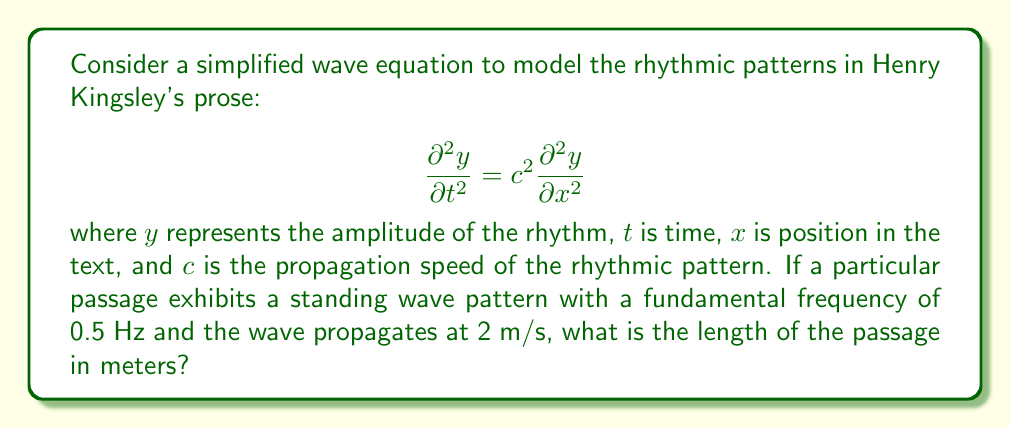Teach me how to tackle this problem. To solve this problem, we'll use the relationship between wavelength, frequency, and wave speed, along with the properties of standing waves.

Step 1: Recall the wave equation: $v = f\lambda$
Where $v$ is wave speed, $f$ is frequency, and $\lambda$ is wavelength.

Step 2: Rearrange the equation to solve for wavelength:
$\lambda = \frac{v}{f}$

Step 3: Substitute the given values:
$v = 2$ m/s (wave speed)
$f = 0.5$ Hz (fundamental frequency)

$\lambda = \frac{2}{0.5} = 4$ m

Step 4: For a standing wave, the length of the medium (in this case, the passage) is related to the wavelength. The fundamental mode of a standing wave has a length equal to half the wavelength.

$L = \frac{\lambda}{2}$

Step 5: Calculate the length of the passage:
$L = \frac{4}{2} = 2$ m

Therefore, the length of the passage exhibiting this rhythmic pattern is 2 meters.
Answer: 2 meters 